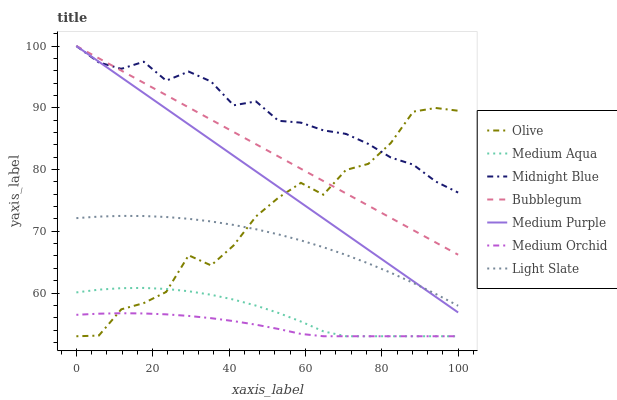Does Light Slate have the minimum area under the curve?
Answer yes or no. No. Does Light Slate have the maximum area under the curve?
Answer yes or no. No. Is Light Slate the smoothest?
Answer yes or no. No. Is Light Slate the roughest?
Answer yes or no. No. Does Light Slate have the lowest value?
Answer yes or no. No. Does Light Slate have the highest value?
Answer yes or no. No. Is Medium Orchid less than Light Slate?
Answer yes or no. Yes. Is Light Slate greater than Medium Orchid?
Answer yes or no. Yes. Does Medium Orchid intersect Light Slate?
Answer yes or no. No. 